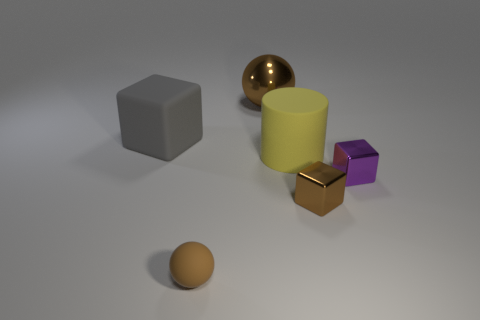Add 1 yellow things. How many objects exist? 7 Subtract all cylinders. How many objects are left? 5 Add 4 big brown metallic objects. How many big brown metallic objects are left? 5 Add 2 tiny blocks. How many tiny blocks exist? 4 Subtract 0 blue spheres. How many objects are left? 6 Subtract all purple balls. Subtract all small brown matte balls. How many objects are left? 5 